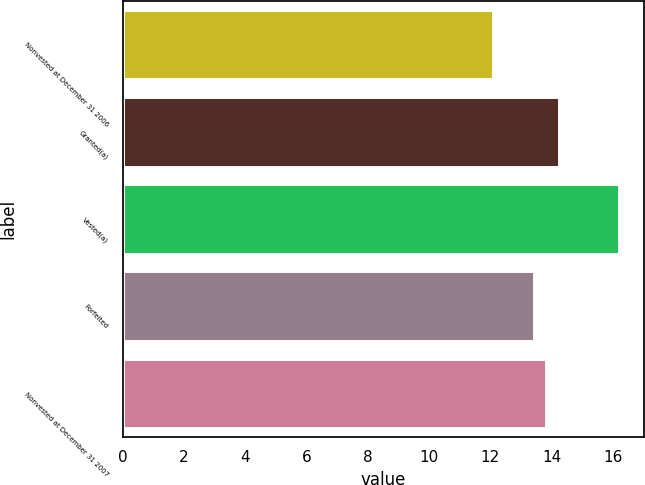<chart> <loc_0><loc_0><loc_500><loc_500><bar_chart><fcel>Nonvested at December 31 2006<fcel>Granted(a)<fcel>Vested(a)<fcel>Forfeited<fcel>Nonvested at December 31 2007<nl><fcel>12.1<fcel>14.23<fcel>16.21<fcel>13.41<fcel>13.82<nl></chart> 